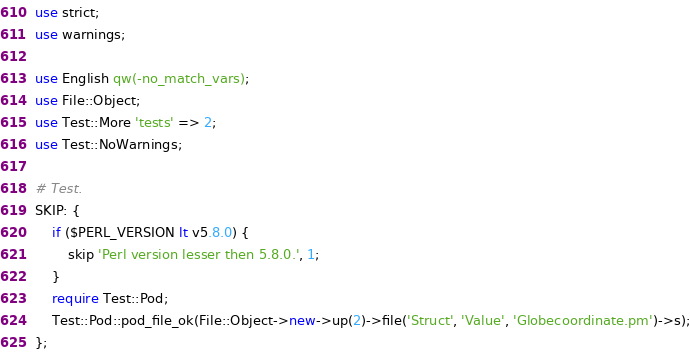Convert code to text. <code><loc_0><loc_0><loc_500><loc_500><_Perl_>use strict;
use warnings;

use English qw(-no_match_vars);
use File::Object;
use Test::More 'tests' => 2;
use Test::NoWarnings;

# Test.
SKIP: {
	if ($PERL_VERSION lt v5.8.0) {
		skip 'Perl version lesser then 5.8.0.', 1;
	}
	require Test::Pod;
	Test::Pod::pod_file_ok(File::Object->new->up(2)->file('Struct', 'Value', 'Globecoordinate.pm')->s);
};
</code> 